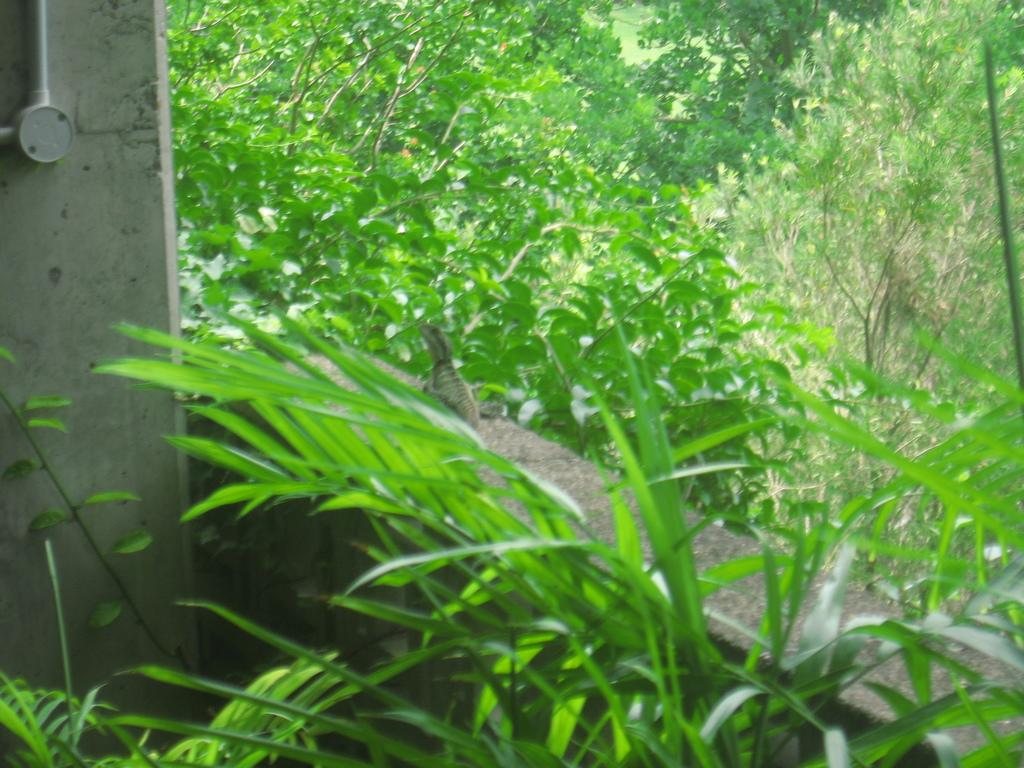What type of vegetation is near the wall in the image? There are plants near the wall in the image. What structure is beside the plants? There is a pillar beside the plants. What animal can be seen on the wall in the image? A garden lizard is visible on the wall. What is located behind the wall in the image? There are plants and trees behind the wall. What level of medical expertise does the doctor have in the image? There is no doctor present in the image. What type of wrist support is visible in the image? There is no wrist support present in the image. 